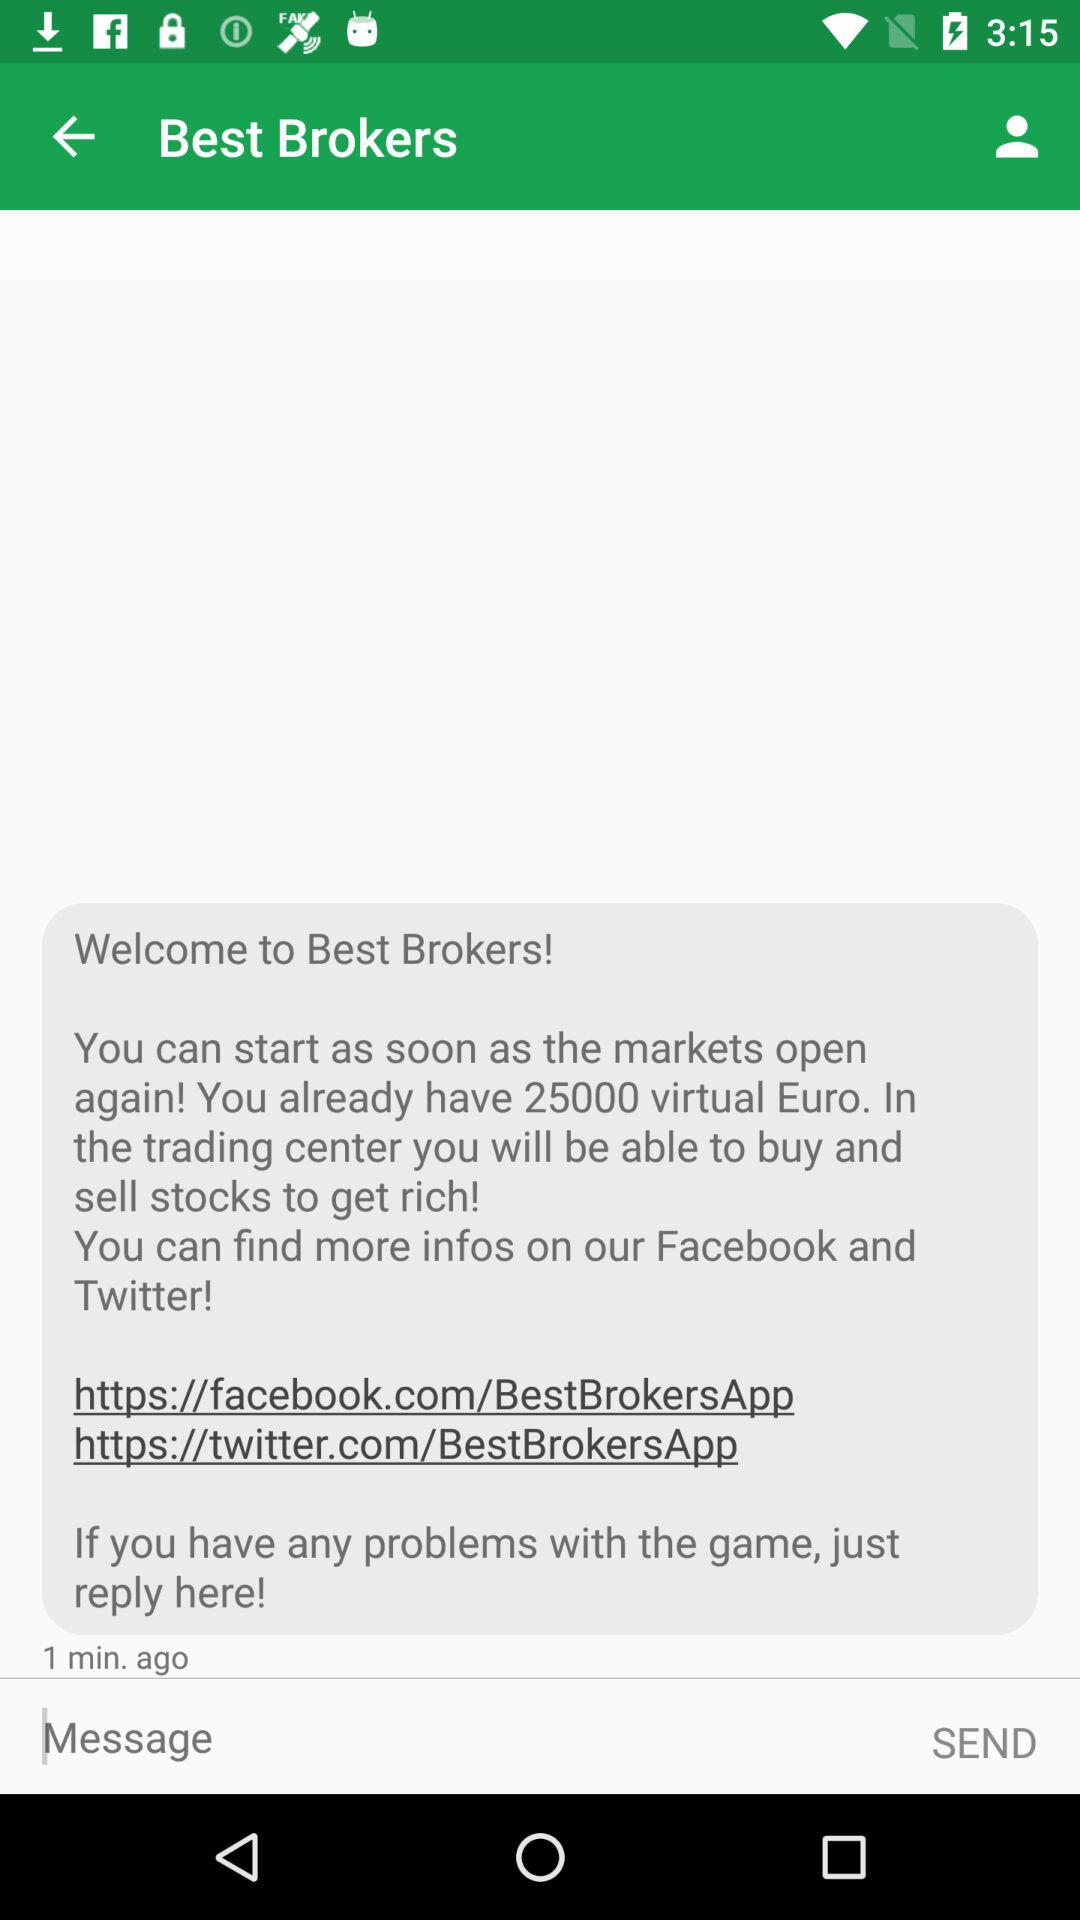How much is 25,000 virtual Euros in virtual U.S. dollars?
When the provided information is insufficient, respond with <no answer>. <no answer> 